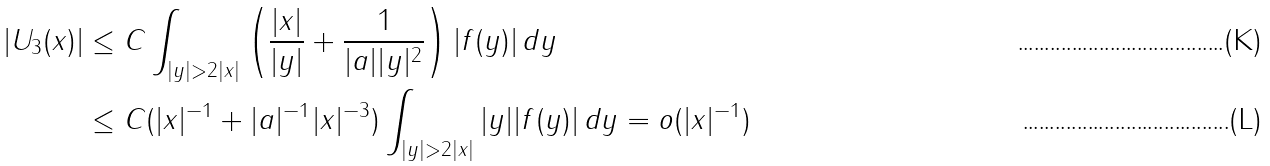Convert formula to latex. <formula><loc_0><loc_0><loc_500><loc_500>| U _ { 3 } ( x ) | & \leq C \int _ { | y | > 2 | x | } \left ( \frac { | x | } { | y | } + \frac { 1 } { | a | | y | ^ { 2 } } \right ) | f ( y ) | \, d y \\ & \leq C ( | x | ^ { - 1 } + | a | ^ { - 1 } | x | ^ { - 3 } ) \int _ { | y | > 2 | x | } | y | | f ( y ) | \, d y = o ( | x | ^ { - 1 } )</formula> 